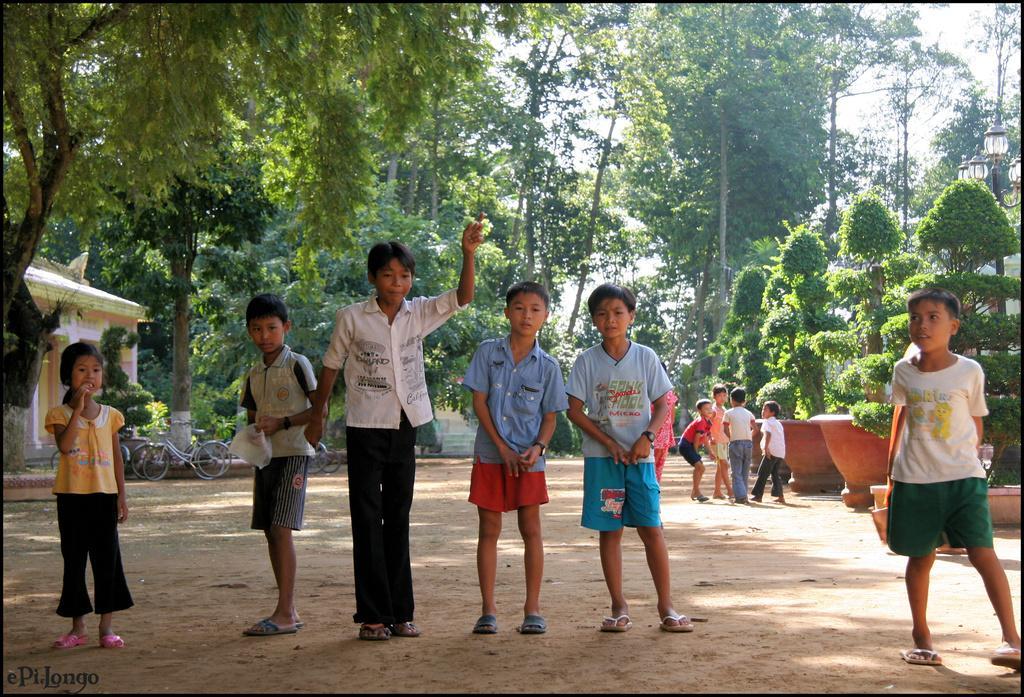Please provide a concise description of this image. In the image in the center we can see few kids were standing and the left side boy is holding plastic paper. In the background we can see sky,clouds,trees,house,wall,roof,plant pots,plants and few more kids. 